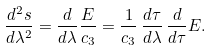<formula> <loc_0><loc_0><loc_500><loc_500>\frac { d ^ { 2 } s } { d \lambda ^ { 2 } } = \frac { d } { d \lambda } \frac { E } { c _ { 3 } } = \frac { 1 } { c _ { 3 } } \, \frac { d \tau } { d \lambda } \, \frac { d } { d \tau } E .</formula> 